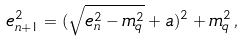<formula> <loc_0><loc_0><loc_500><loc_500>e _ { n + 1 } ^ { 2 } = ( \sqrt { e _ { n } ^ { 2 } - m _ { q } ^ { 2 } } + a ) ^ { 2 } + m _ { q } ^ { 2 } \, ,</formula> 